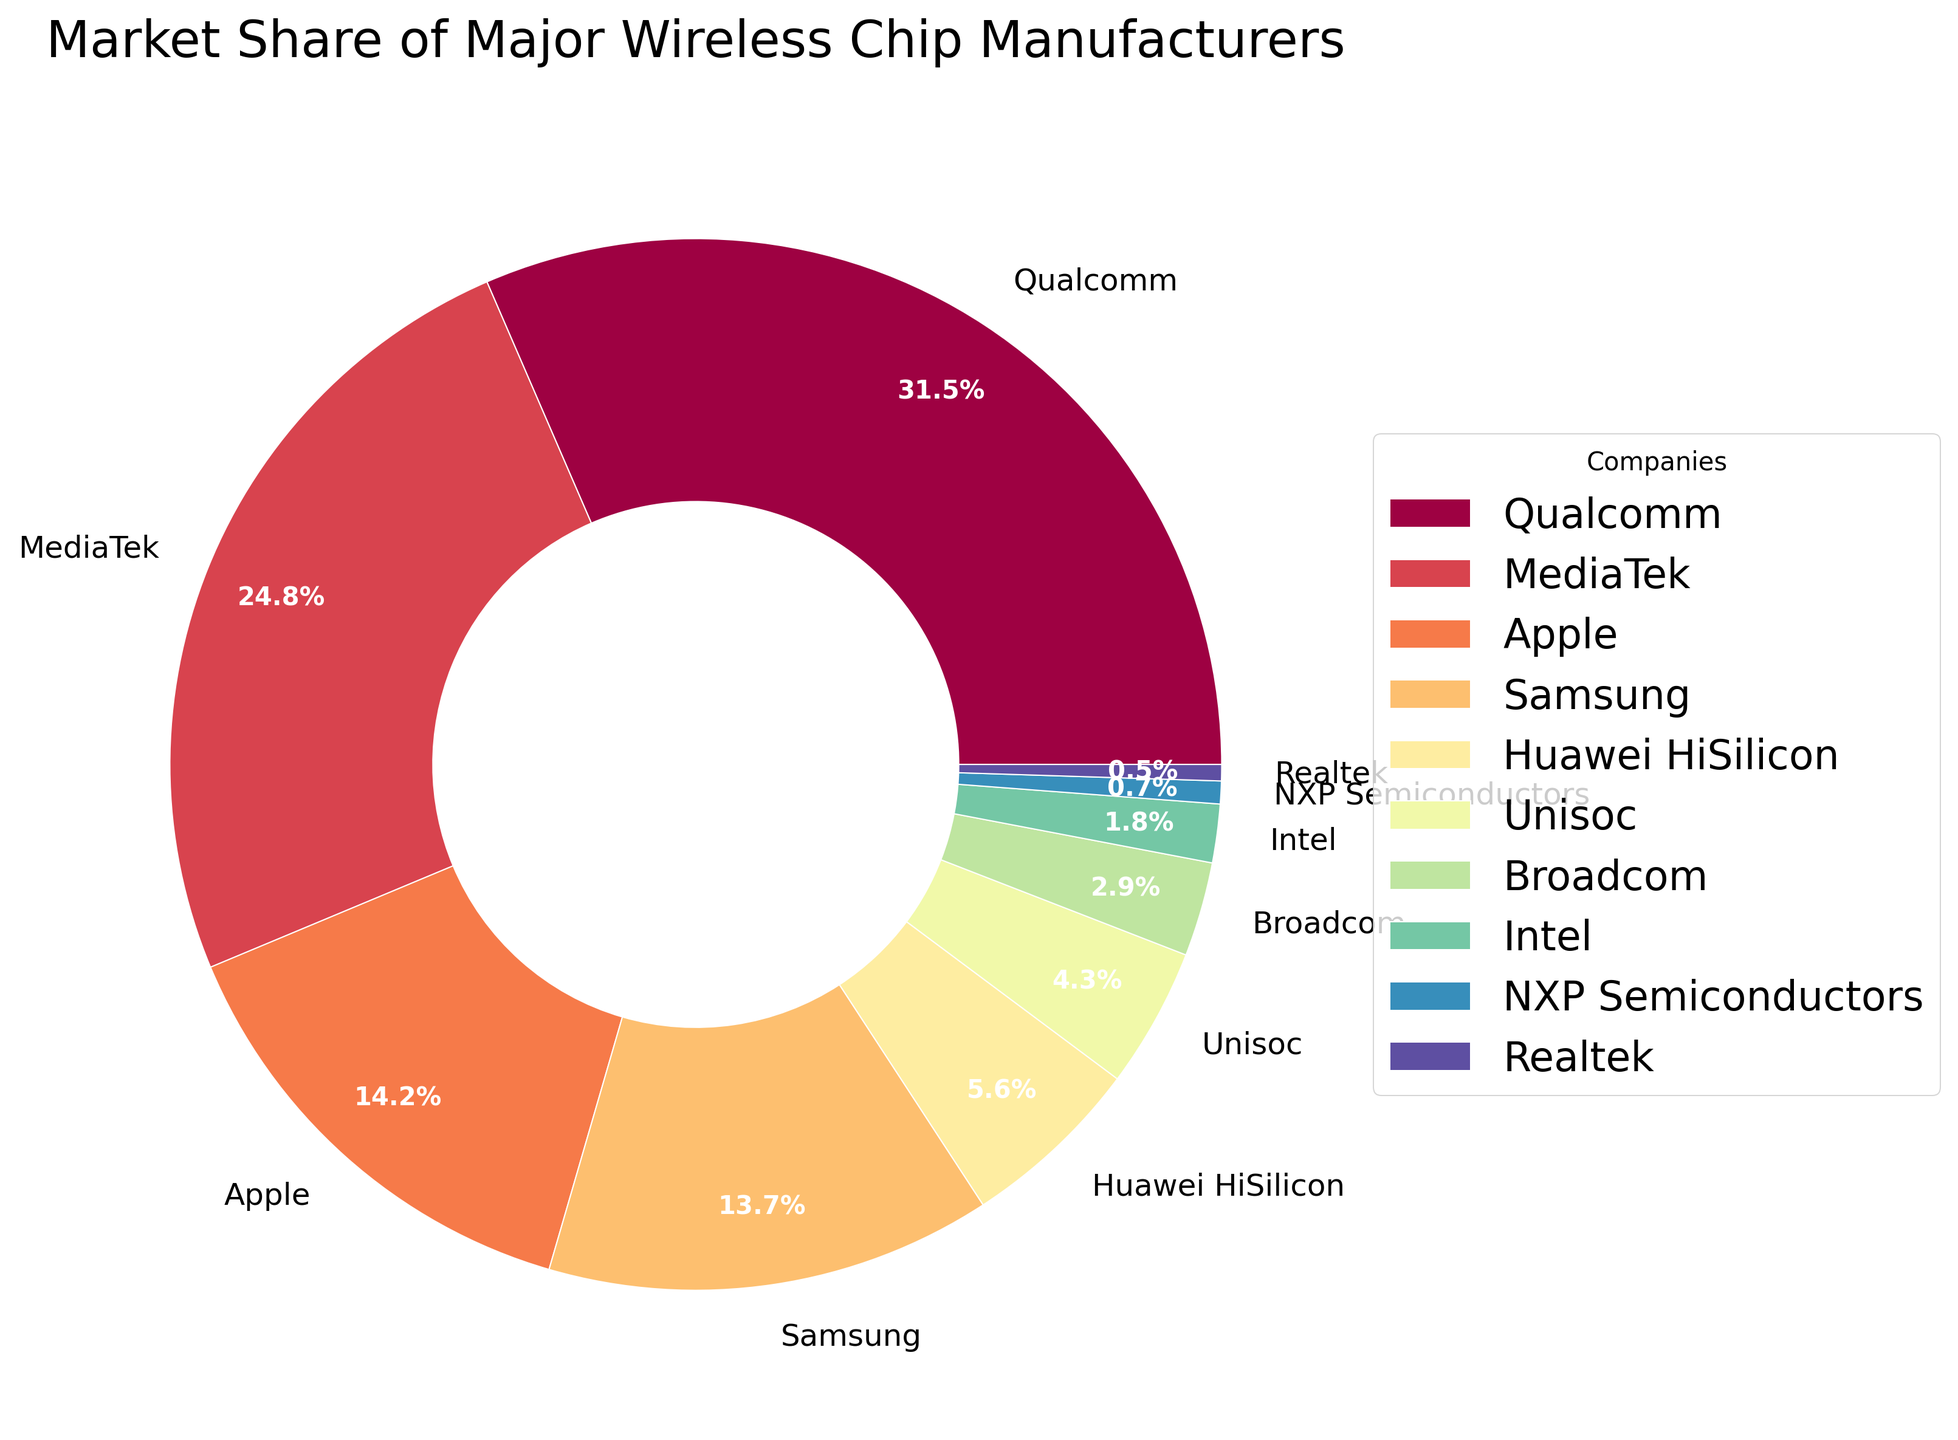Which company has the largest market share? The figure shows a pie chart with companies and their market shares. By observing the wedges, we can see that Qualcomm has the largest wedge, indicating it has the largest market share.
Answer: Qualcomm What is the combined market share of Apple and Samsung? Apple has a market share of 14.2% and Samsung has 13.7%. Adding these together gives 14.2% + 13.7% = 27.9%.
Answer: 27.9% Which companies have a market share smaller than 1%? From the pie chart, we see that NXP Semiconductors has 0.7% and Realtek has 0.5%, both of which are less than 1%.
Answer: NXP Semiconductors, Realtek What is the difference in market share between MediaTek and Huawei HiSilicon? MediaTek has a market share of 24.8% and Huawei HiSilicon has 5.6%. The difference is 24.8% - 5.6% = 19.2%.
Answer: 19.2% What is the total market share of companies with a market share greater than 10%? Qualcomm has 31.5%, MediaTek has 24.8%, Apple has 14.2%, and Samsung has 13.7%. Adding these together gives 31.5% + 24.8% + 14.2% + 13.7% = 84.2%.
Answer: 84.2% Which companies have a blue shade in their wedge? Observing the color scheme used in the pie chart, we see that MediaTek and Huawei HiSilicon show a blue shade in their wedges.
Answer: MediaTek, Huawei HiSilicon What percentage of the market is controlled by companies other than Qualcomm and MediaTek? The total market share of Qualcomm and MediaTek is 31.5% + 24.8% = 56.3%. The rest is 100% - 56.3% = 43.7%.
Answer: 43.7% Which company has nearly a fifth of the total market share? By checking the labels, MediaTek has a market share close to a fifth (20%) at 24.8%.
Answer: MediaTek 